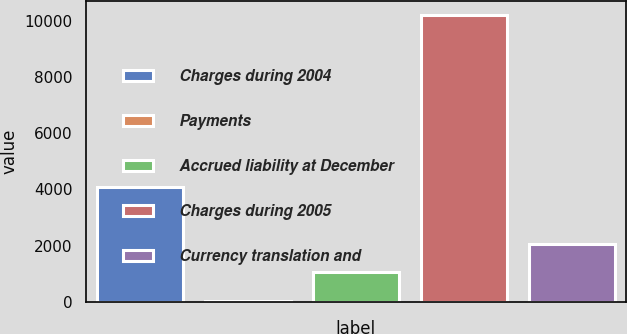Convert chart to OTSL. <chart><loc_0><loc_0><loc_500><loc_500><bar_chart><fcel>Charges during 2004<fcel>Payments<fcel>Accrued liability at December<fcel>Charges during 2005<fcel>Currency translation and<nl><fcel>4103<fcel>35<fcel>1052<fcel>10205<fcel>2069<nl></chart> 